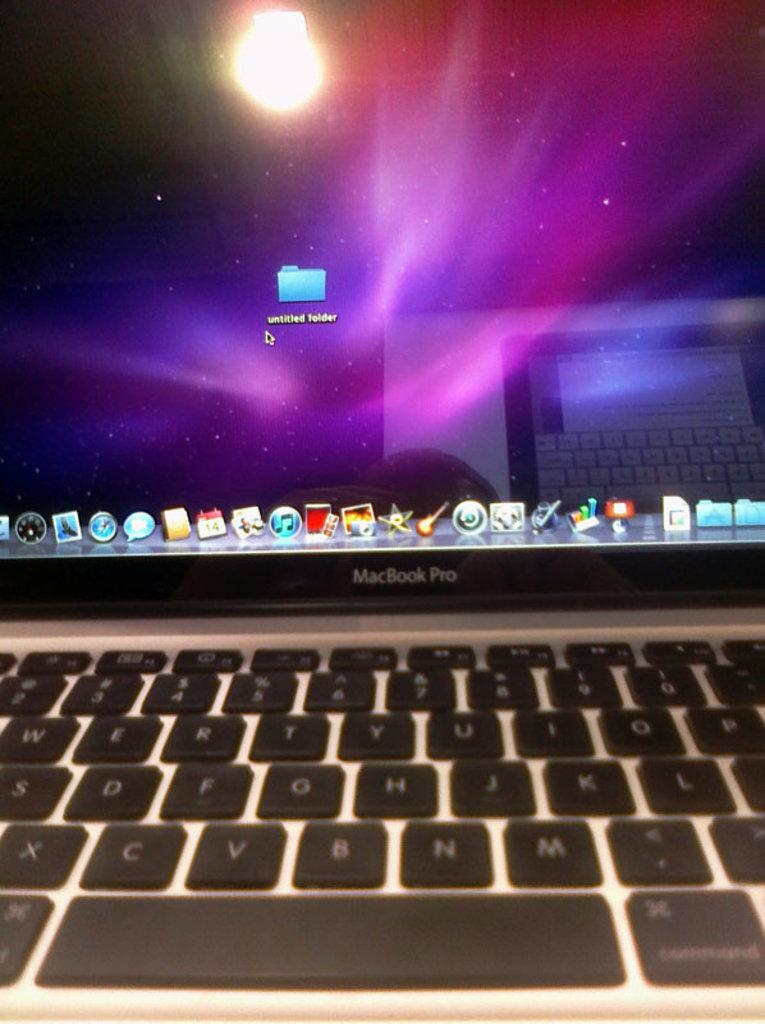<image>
Share a concise interpretation of the image provided. Laptop showing a purple screen and folder titled "Untitled". 